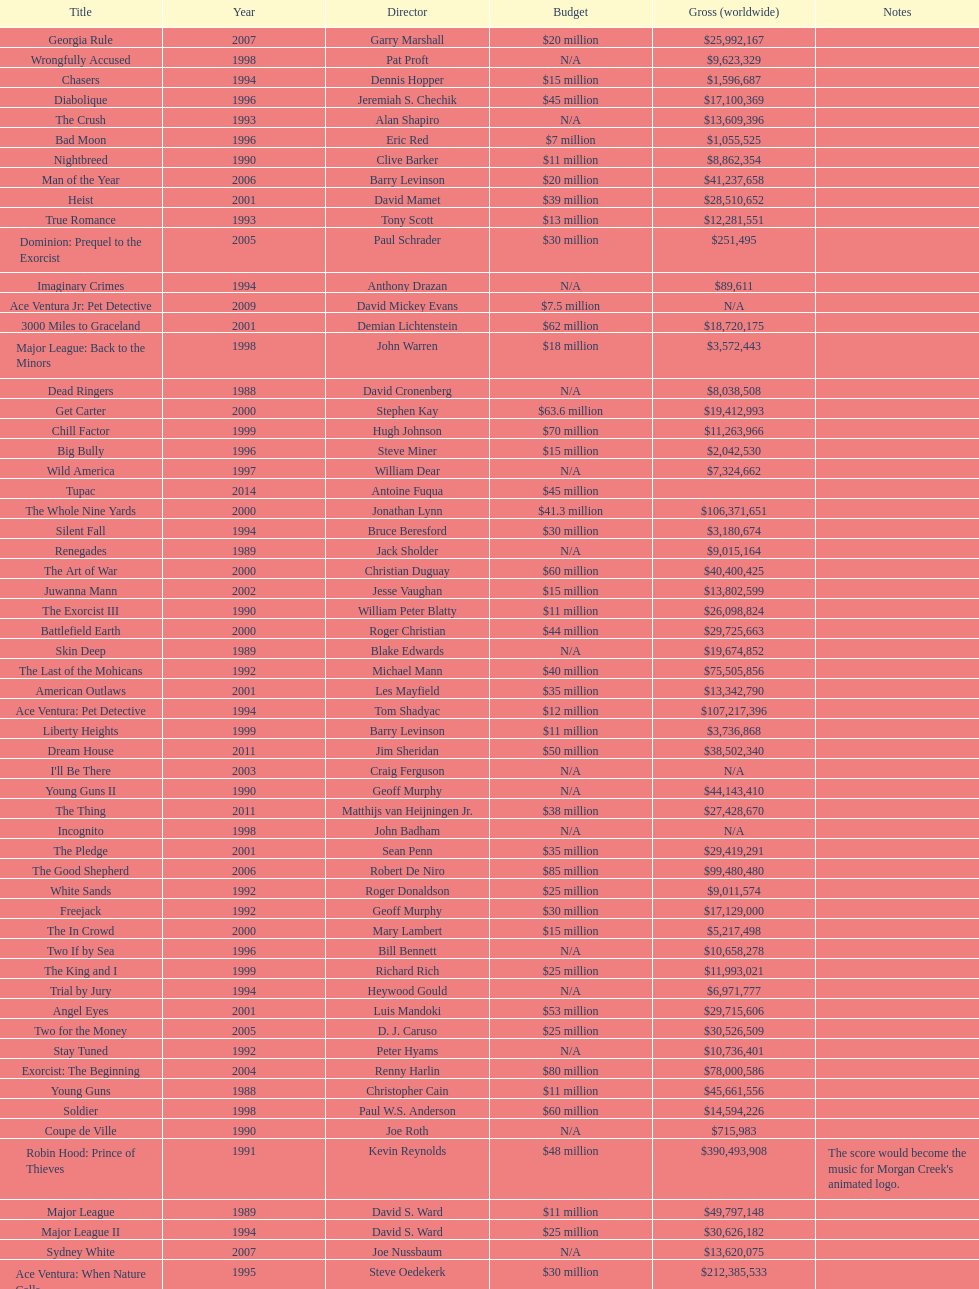What was the last movie morgan creek made for a budget under thirty million? Ace Ventura Jr: Pet Detective. 